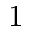<formula> <loc_0><loc_0><loc_500><loc_500>1</formula> 